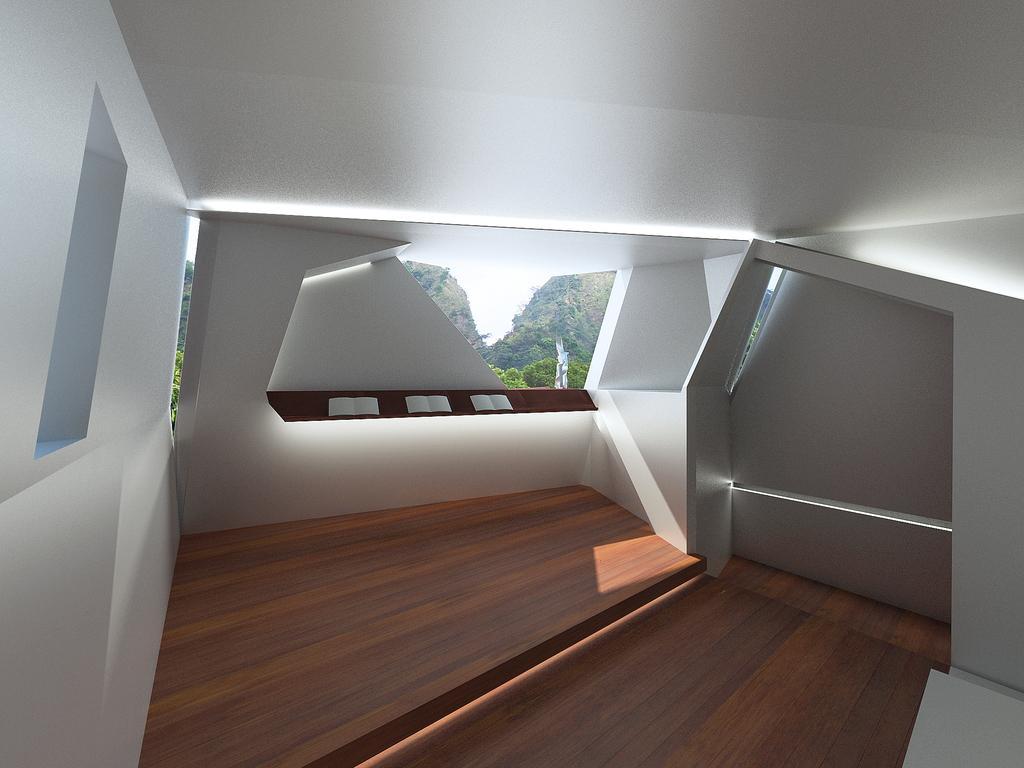Describe this image in one or two sentences. This is the inside picture of the building. In this image there are books on the platform. There is a wall. At the bottom of the image there is a floor. There is a window through which we can see trees and sky. 